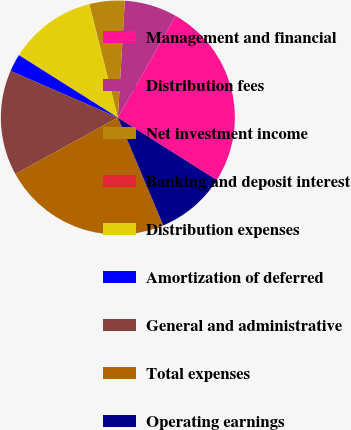Convert chart to OTSL. <chart><loc_0><loc_0><loc_500><loc_500><pie_chart><fcel>Management and financial<fcel>Distribution fees<fcel>Net investment income<fcel>Banking and deposit interest<fcel>Distribution expenses<fcel>Amortization of deferred<fcel>General and administrative<fcel>Total expenses<fcel>Operating earnings<nl><fcel>25.75%<fcel>7.27%<fcel>4.86%<fcel>0.02%<fcel>12.11%<fcel>2.44%<fcel>14.53%<fcel>23.34%<fcel>9.69%<nl></chart> 